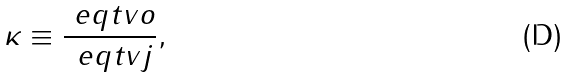<formula> <loc_0><loc_0><loc_500><loc_500>\kappa \equiv \frac { \ e q t { v } { o } } { \ e q t { v } { j } } ,</formula> 